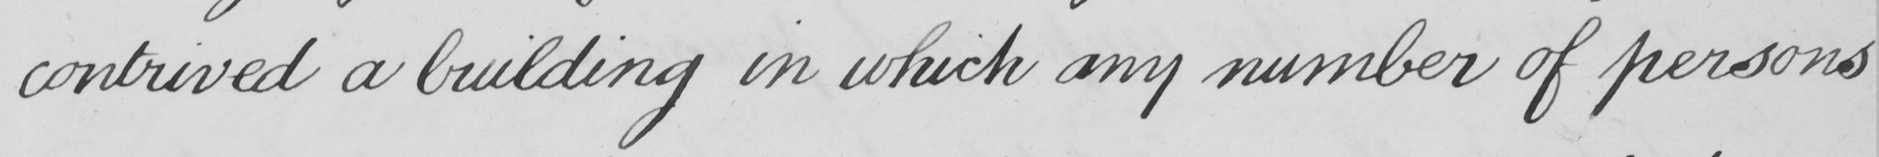What is written in this line of handwriting? contrived a building in which any number of persons 